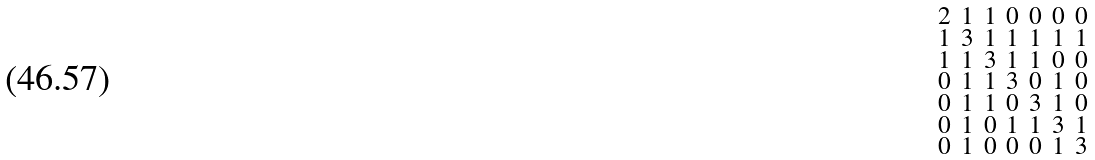<formula> <loc_0><loc_0><loc_500><loc_500>\begin{smallmatrix} 2 & 1 & 1 & 0 & 0 & 0 & 0 \\ 1 & 3 & 1 & 1 & 1 & 1 & 1 \\ 1 & 1 & 3 & 1 & 1 & 0 & 0 \\ 0 & 1 & 1 & 3 & 0 & 1 & 0 \\ 0 & 1 & 1 & 0 & 3 & 1 & 0 \\ 0 & 1 & 0 & 1 & 1 & 3 & 1 \\ 0 & 1 & 0 & 0 & 0 & 1 & 3 \end{smallmatrix}</formula> 